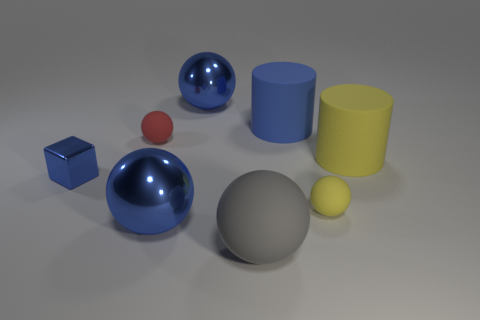What is the material of the big cylinder that is the same color as the metallic block?
Your response must be concise. Rubber. What is the size of the yellow cylinder?
Offer a very short reply. Large. There is a big rubber object that is the same color as the cube; what is its shape?
Offer a very short reply. Cylinder. What number of blocks are either large red things or large blue objects?
Make the answer very short. 0. Are there an equal number of rubber balls to the left of the shiny cube and gray balls right of the blue cylinder?
Your answer should be compact. Yes. The gray object that is the same shape as the red object is what size?
Provide a succinct answer. Large. What is the size of the object that is both behind the blue block and on the right side of the large blue matte cylinder?
Your answer should be compact. Large. There is a tiny red matte thing; are there any blue spheres in front of it?
Ensure brevity in your answer.  Yes. How many things are cylinders behind the small red thing or small brown things?
Make the answer very short. 1. How many yellow rubber cylinders are behind the rubber ball to the left of the gray matte sphere?
Your response must be concise. 0. 